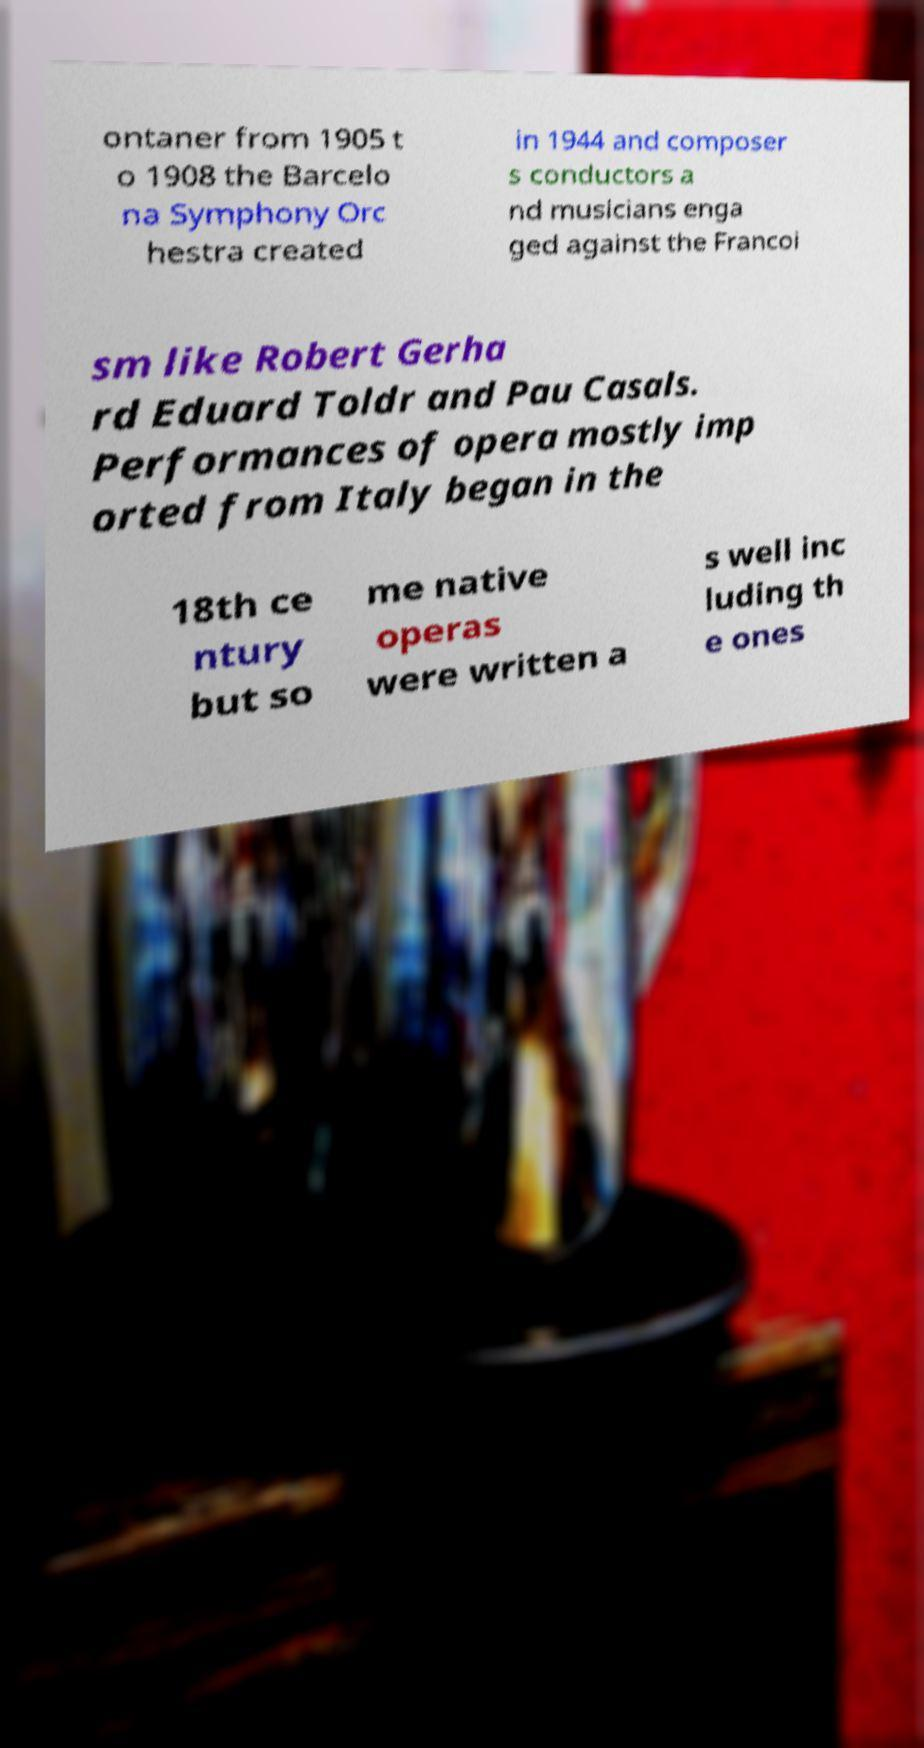I need the written content from this picture converted into text. Can you do that? ontaner from 1905 t o 1908 the Barcelo na Symphony Orc hestra created in 1944 and composer s conductors a nd musicians enga ged against the Francoi sm like Robert Gerha rd Eduard Toldr and Pau Casals. Performances of opera mostly imp orted from Italy began in the 18th ce ntury but so me native operas were written a s well inc luding th e ones 